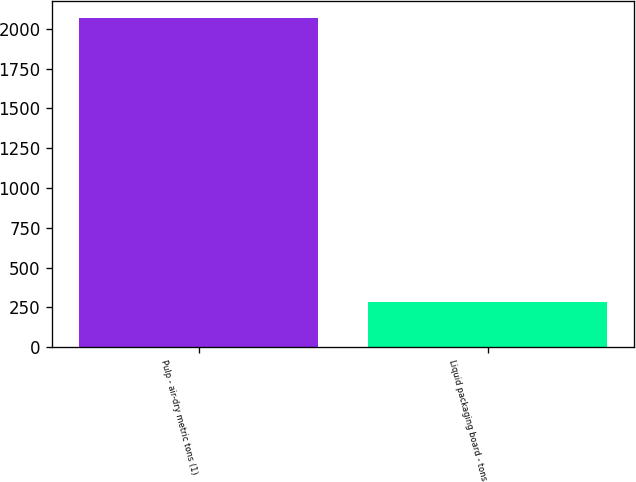Convert chart to OTSL. <chart><loc_0><loc_0><loc_500><loc_500><bar_chart><fcel>Pulp - air-dry metric tons (1)<fcel>Liquid packaging board - tons<nl><fcel>2070<fcel>286<nl></chart> 